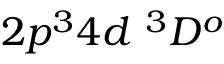<formula> <loc_0><loc_0><loc_500><loc_500>{ 2 p ^ { 3 } 4 d ^ { 3 } D ^ { o } }</formula> 